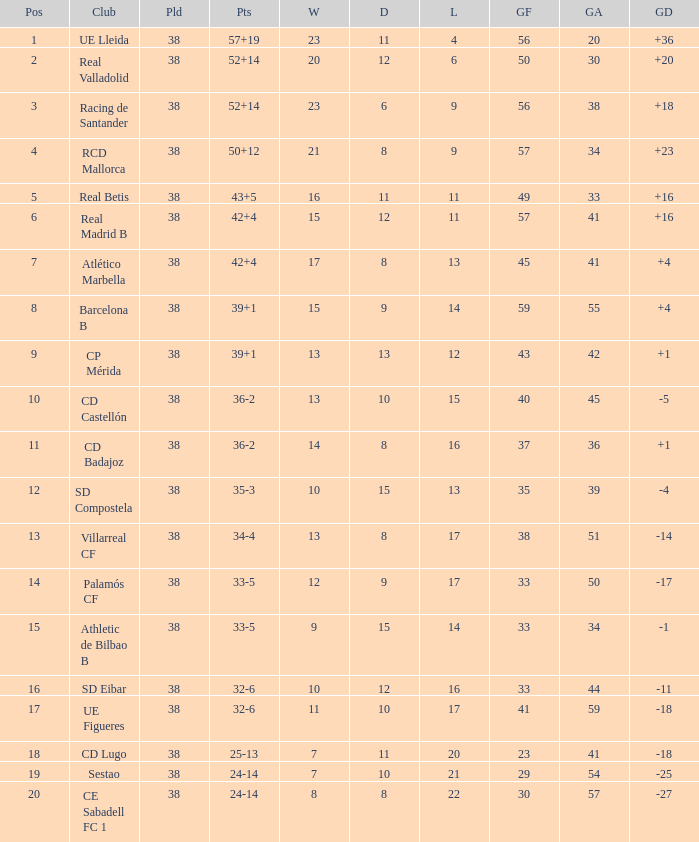What is the highest number of loss with a 7 position and more than 45 goals? None. 